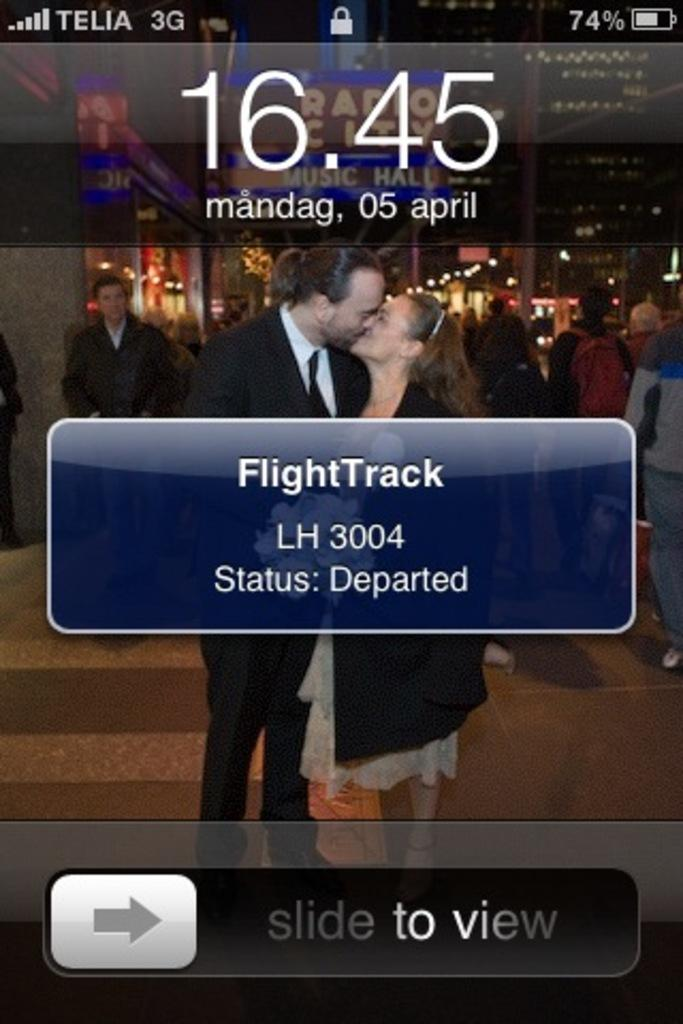What type of screen is displayed in the image? The image is a lock screen of a mobile device. What information can be found on the lock screen? The date, time, location, text, and numerical numbers are visible on the lock screen. Can you describe the people in the image? There are people visible in the image, and a woman and a man are kissing. What type of linen is used to cover the snails in the image? There are no snails or linen present in the image. What level of detail can be seen in the image? The level of detail in the image cannot be determined without additional information about the resolution or quality of the image. 